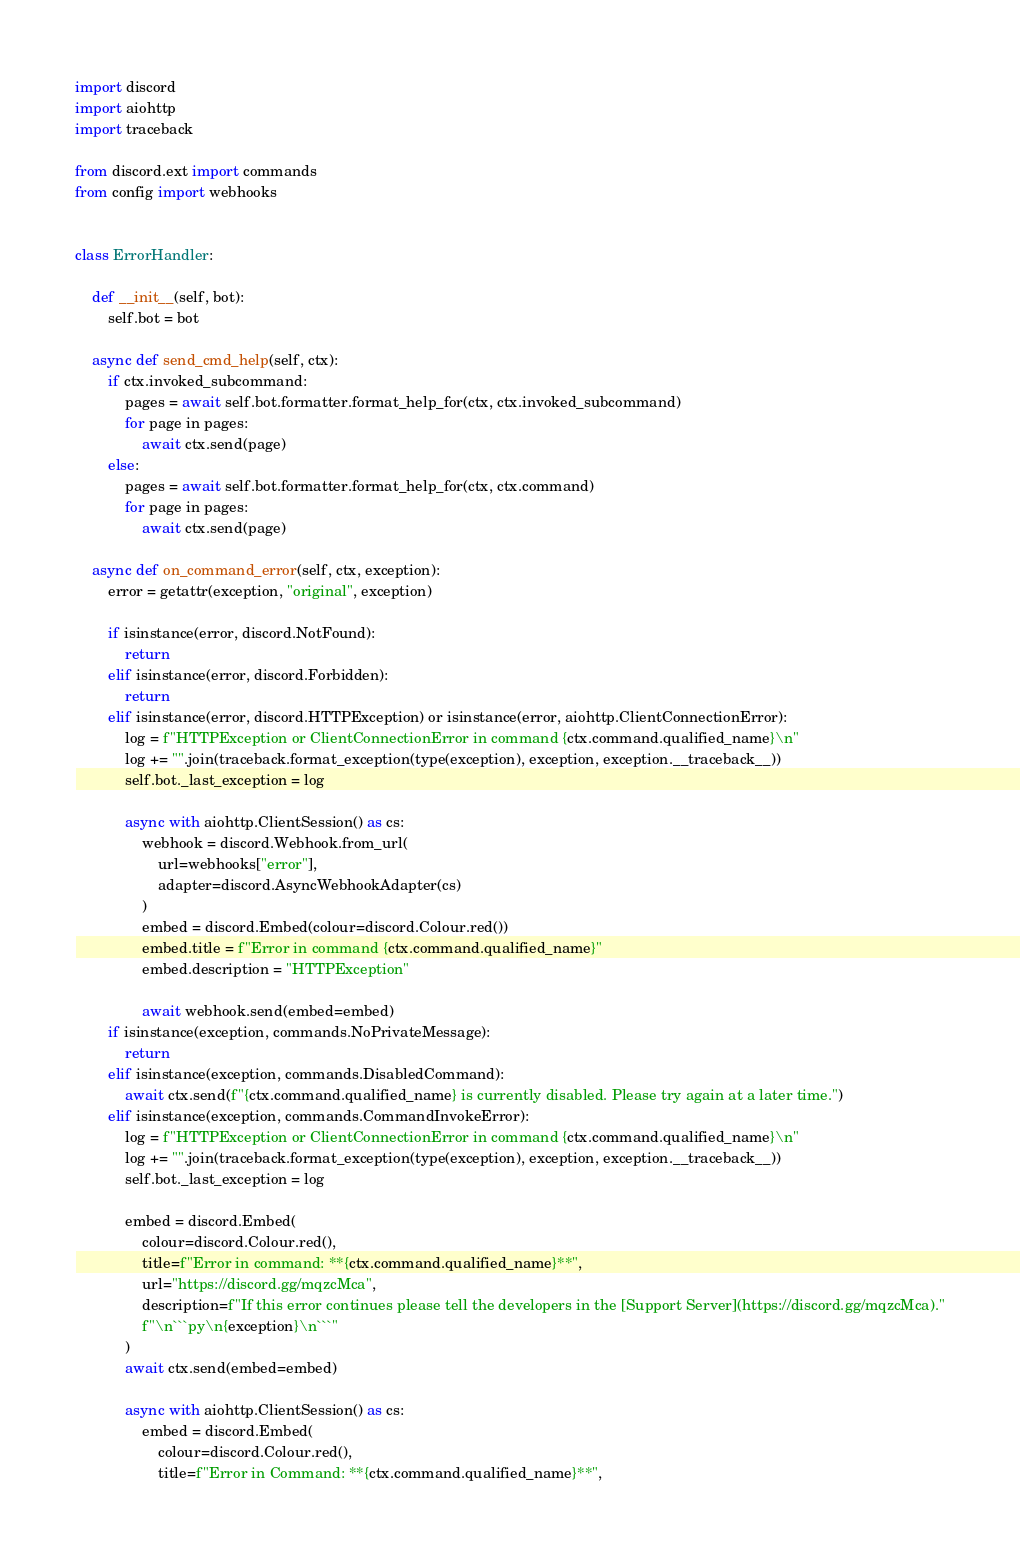<code> <loc_0><loc_0><loc_500><loc_500><_Python_>import discord
import aiohttp
import traceback

from discord.ext import commands
from config import webhooks


class ErrorHandler:

    def __init__(self, bot):
        self.bot = bot

    async def send_cmd_help(self, ctx):
        if ctx.invoked_subcommand:
            pages = await self.bot.formatter.format_help_for(ctx, ctx.invoked_subcommand)
            for page in pages:
                await ctx.send(page)
        else:
            pages = await self.bot.formatter.format_help_for(ctx, ctx.command)
            for page in pages:
                await ctx.send(page)

    async def on_command_error(self, ctx, exception):
        error = getattr(exception, "original", exception)

        if isinstance(error, discord.NotFound):
            return
        elif isinstance(error, discord.Forbidden):
            return
        elif isinstance(error, discord.HTTPException) or isinstance(error, aiohttp.ClientConnectionError):
            log = f"HTTPException or ClientConnectionError in command {ctx.command.qualified_name}\n"
            log += "".join(traceback.format_exception(type(exception), exception, exception.__traceback__))
            self.bot._last_exception = log

            async with aiohttp.ClientSession() as cs:
                webhook = discord.Webhook.from_url(
                    url=webhooks["error"],
                    adapter=discord.AsyncWebhookAdapter(cs)
                )
                embed = discord.Embed(colour=discord.Colour.red())
                embed.title = f"Error in command {ctx.command.qualified_name}"
                embed.description = "HTTPException"

                await webhook.send(embed=embed)
        if isinstance(exception, commands.NoPrivateMessage):
            return
        elif isinstance(exception, commands.DisabledCommand):
            await ctx.send(f"{ctx.command.qualified_name} is currently disabled. Please try again at a later time.")
        elif isinstance(exception, commands.CommandInvokeError):
            log = f"HTTPException or ClientConnectionError in command {ctx.command.qualified_name}\n"
            log += "".join(traceback.format_exception(type(exception), exception, exception.__traceback__))
            self.bot._last_exception = log

            embed = discord.Embed(
                colour=discord.Colour.red(),
                title=f"Error in command: **{ctx.command.qualified_name}**",
                url="https://discord.gg/mqzcMca",
                description=f"If this error continues please tell the developers in the [Support Server](https://discord.gg/mqzcMca)."
                f"\n```py\n{exception}\n```"
            )
            await ctx.send(embed=embed)

            async with aiohttp.ClientSession() as cs:
                embed = discord.Embed(
                    colour=discord.Colour.red(),
                    title=f"Error in Command: **{ctx.command.qualified_name}**",</code> 